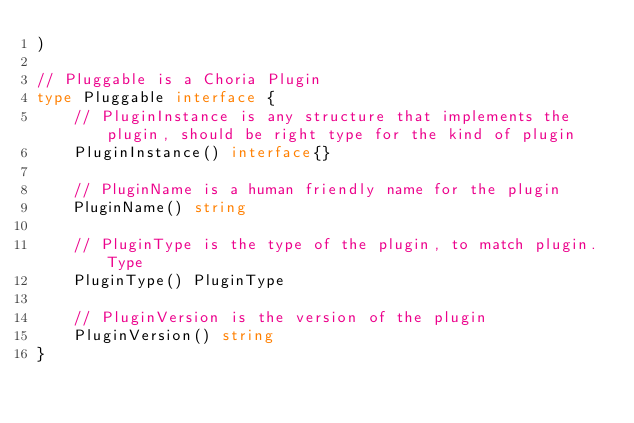Convert code to text. <code><loc_0><loc_0><loc_500><loc_500><_Go_>)

// Pluggable is a Choria Plugin
type Pluggable interface {
	// PluginInstance is any structure that implements the plugin, should be right type for the kind of plugin
	PluginInstance() interface{}

	// PluginName is a human friendly name for the plugin
	PluginName() string

	// PluginType is the type of the plugin, to match plugin.Type
	PluginType() PluginType

	// PluginVersion is the version of the plugin
	PluginVersion() string
}
</code> 